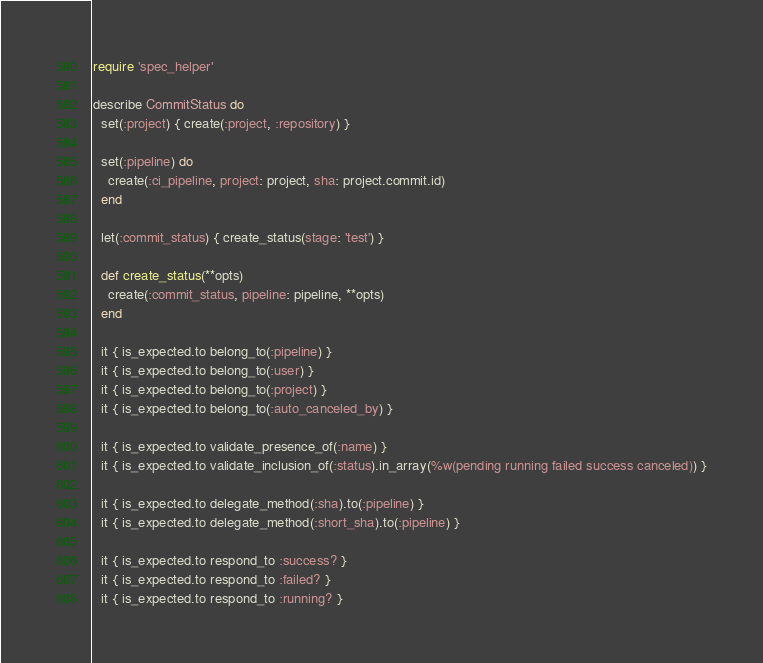<code> <loc_0><loc_0><loc_500><loc_500><_Ruby_>require 'spec_helper'

describe CommitStatus do
  set(:project) { create(:project, :repository) }

  set(:pipeline) do
    create(:ci_pipeline, project: project, sha: project.commit.id)
  end

  let(:commit_status) { create_status(stage: 'test') }

  def create_status(**opts)
    create(:commit_status, pipeline: pipeline, **opts)
  end

  it { is_expected.to belong_to(:pipeline) }
  it { is_expected.to belong_to(:user) }
  it { is_expected.to belong_to(:project) }
  it { is_expected.to belong_to(:auto_canceled_by) }

  it { is_expected.to validate_presence_of(:name) }
  it { is_expected.to validate_inclusion_of(:status).in_array(%w(pending running failed success canceled)) }

  it { is_expected.to delegate_method(:sha).to(:pipeline) }
  it { is_expected.to delegate_method(:short_sha).to(:pipeline) }

  it { is_expected.to respond_to :success? }
  it { is_expected.to respond_to :failed? }
  it { is_expected.to respond_to :running? }</code> 